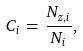Convert formula to latex. <formula><loc_0><loc_0><loc_500><loc_500>C _ { i } \, = \, \frac { N _ { z , i } } { N _ { i } } ,</formula> 